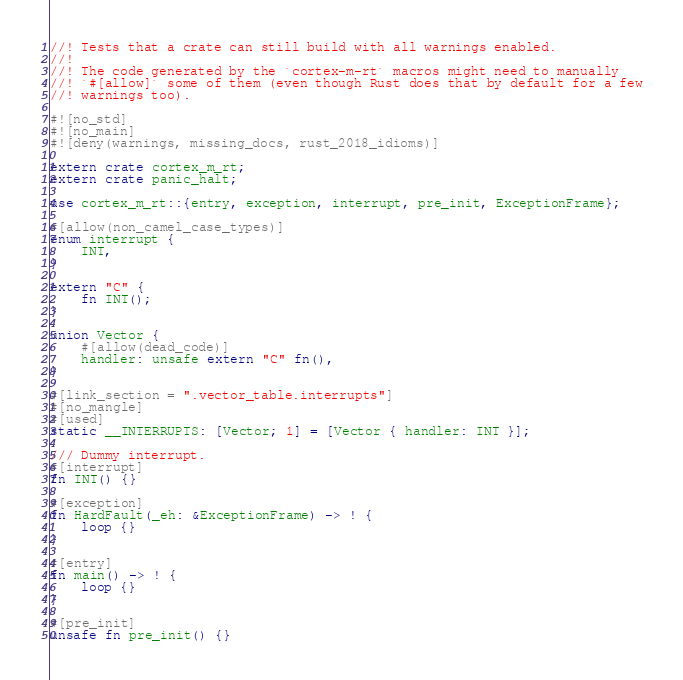Convert code to text. <code><loc_0><loc_0><loc_500><loc_500><_Rust_>//! Tests that a crate can still build with all warnings enabled.
//!
//! The code generated by the `cortex-m-rt` macros might need to manually
//! `#[allow]` some of them (even though Rust does that by default for a few
//! warnings too).

#![no_std]
#![no_main]
#![deny(warnings, missing_docs, rust_2018_idioms)]

extern crate cortex_m_rt;
extern crate panic_halt;

use cortex_m_rt::{entry, exception, interrupt, pre_init, ExceptionFrame};

#[allow(non_camel_case_types)]
enum interrupt {
    INT,
}

extern "C" {
    fn INT();
}

union Vector {
    #[allow(dead_code)]
    handler: unsafe extern "C" fn(),
}

#[link_section = ".vector_table.interrupts"]
#[no_mangle]
#[used]
static __INTERRUPTS: [Vector; 1] = [Vector { handler: INT }];

/// Dummy interrupt.
#[interrupt]
fn INT() {}

#[exception]
fn HardFault(_eh: &ExceptionFrame) -> ! {
    loop {}
}

#[entry]
fn main() -> ! {
    loop {}
}

#[pre_init]
unsafe fn pre_init() {}
</code> 